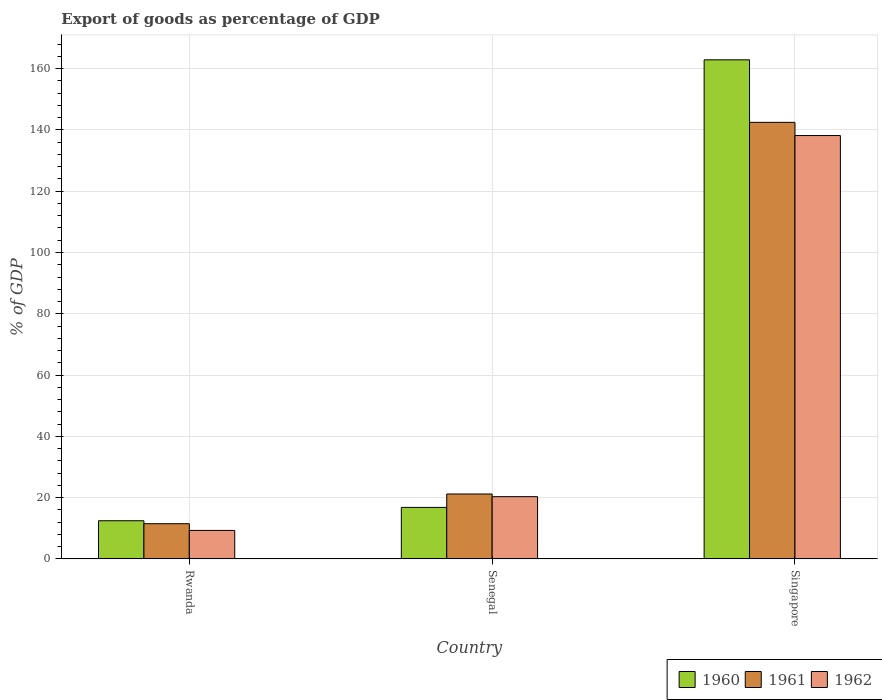How many different coloured bars are there?
Provide a succinct answer. 3. How many groups of bars are there?
Your answer should be very brief. 3. Are the number of bars per tick equal to the number of legend labels?
Provide a succinct answer. Yes. Are the number of bars on each tick of the X-axis equal?
Your answer should be compact. Yes. How many bars are there on the 3rd tick from the right?
Provide a succinct answer. 3. What is the label of the 1st group of bars from the left?
Ensure brevity in your answer.  Rwanda. In how many cases, is the number of bars for a given country not equal to the number of legend labels?
Your response must be concise. 0. What is the export of goods as percentage of GDP in 1960 in Senegal?
Offer a terse response. 16.79. Across all countries, what is the maximum export of goods as percentage of GDP in 1962?
Offer a very short reply. 138.18. Across all countries, what is the minimum export of goods as percentage of GDP in 1961?
Offer a terse response. 11.48. In which country was the export of goods as percentage of GDP in 1960 maximum?
Your response must be concise. Singapore. In which country was the export of goods as percentage of GDP in 1961 minimum?
Ensure brevity in your answer.  Rwanda. What is the total export of goods as percentage of GDP in 1960 in the graph?
Provide a succinct answer. 192.12. What is the difference between the export of goods as percentage of GDP in 1960 in Rwanda and that in Senegal?
Provide a succinct answer. -4.36. What is the difference between the export of goods as percentage of GDP in 1962 in Singapore and the export of goods as percentage of GDP in 1960 in Senegal?
Your response must be concise. 121.39. What is the average export of goods as percentage of GDP in 1960 per country?
Offer a terse response. 64.04. What is the difference between the export of goods as percentage of GDP of/in 1962 and export of goods as percentage of GDP of/in 1960 in Rwanda?
Give a very brief answer. -3.16. In how many countries, is the export of goods as percentage of GDP in 1960 greater than 32 %?
Make the answer very short. 1. What is the ratio of the export of goods as percentage of GDP in 1960 in Rwanda to that in Singapore?
Ensure brevity in your answer.  0.08. Is the difference between the export of goods as percentage of GDP in 1962 in Senegal and Singapore greater than the difference between the export of goods as percentage of GDP in 1960 in Senegal and Singapore?
Your answer should be very brief. Yes. What is the difference between the highest and the second highest export of goods as percentage of GDP in 1961?
Provide a succinct answer. -9.7. What is the difference between the highest and the lowest export of goods as percentage of GDP in 1960?
Ensure brevity in your answer.  150.46. Is the sum of the export of goods as percentage of GDP in 1962 in Senegal and Singapore greater than the maximum export of goods as percentage of GDP in 1960 across all countries?
Your response must be concise. No. Is it the case that in every country, the sum of the export of goods as percentage of GDP in 1962 and export of goods as percentage of GDP in 1960 is greater than the export of goods as percentage of GDP in 1961?
Offer a very short reply. Yes. How many bars are there?
Offer a terse response. 9. Are all the bars in the graph horizontal?
Make the answer very short. No. How many countries are there in the graph?
Give a very brief answer. 3. Are the values on the major ticks of Y-axis written in scientific E-notation?
Your answer should be very brief. No. Does the graph contain any zero values?
Keep it short and to the point. No. Does the graph contain grids?
Offer a terse response. Yes. Where does the legend appear in the graph?
Offer a terse response. Bottom right. How many legend labels are there?
Make the answer very short. 3. How are the legend labels stacked?
Give a very brief answer. Horizontal. What is the title of the graph?
Your answer should be compact. Export of goods as percentage of GDP. What is the label or title of the X-axis?
Your answer should be very brief. Country. What is the label or title of the Y-axis?
Ensure brevity in your answer.  % of GDP. What is the % of GDP in 1960 in Rwanda?
Ensure brevity in your answer.  12.44. What is the % of GDP of 1961 in Rwanda?
Ensure brevity in your answer.  11.48. What is the % of GDP of 1962 in Rwanda?
Provide a short and direct response. 9.28. What is the % of GDP of 1960 in Senegal?
Your response must be concise. 16.79. What is the % of GDP of 1961 in Senegal?
Keep it short and to the point. 21.17. What is the % of GDP in 1962 in Senegal?
Your response must be concise. 20.3. What is the % of GDP of 1960 in Singapore?
Offer a very short reply. 162.89. What is the % of GDP in 1961 in Singapore?
Give a very brief answer. 142.48. What is the % of GDP of 1962 in Singapore?
Ensure brevity in your answer.  138.18. Across all countries, what is the maximum % of GDP of 1960?
Make the answer very short. 162.89. Across all countries, what is the maximum % of GDP of 1961?
Provide a succinct answer. 142.48. Across all countries, what is the maximum % of GDP in 1962?
Ensure brevity in your answer.  138.18. Across all countries, what is the minimum % of GDP of 1960?
Keep it short and to the point. 12.44. Across all countries, what is the minimum % of GDP in 1961?
Offer a very short reply. 11.48. Across all countries, what is the minimum % of GDP of 1962?
Provide a short and direct response. 9.28. What is the total % of GDP in 1960 in the graph?
Offer a very short reply. 192.12. What is the total % of GDP of 1961 in the graph?
Offer a very short reply. 175.13. What is the total % of GDP in 1962 in the graph?
Ensure brevity in your answer.  167.76. What is the difference between the % of GDP of 1960 in Rwanda and that in Senegal?
Provide a short and direct response. -4.36. What is the difference between the % of GDP in 1961 in Rwanda and that in Senegal?
Offer a very short reply. -9.7. What is the difference between the % of GDP of 1962 in Rwanda and that in Senegal?
Give a very brief answer. -11.02. What is the difference between the % of GDP of 1960 in Rwanda and that in Singapore?
Your answer should be very brief. -150.46. What is the difference between the % of GDP in 1961 in Rwanda and that in Singapore?
Provide a succinct answer. -131.01. What is the difference between the % of GDP of 1962 in Rwanda and that in Singapore?
Your answer should be very brief. -128.9. What is the difference between the % of GDP in 1960 in Senegal and that in Singapore?
Make the answer very short. -146.1. What is the difference between the % of GDP of 1961 in Senegal and that in Singapore?
Give a very brief answer. -121.31. What is the difference between the % of GDP of 1962 in Senegal and that in Singapore?
Ensure brevity in your answer.  -117.88. What is the difference between the % of GDP of 1960 in Rwanda and the % of GDP of 1961 in Senegal?
Keep it short and to the point. -8.74. What is the difference between the % of GDP in 1960 in Rwanda and the % of GDP in 1962 in Senegal?
Your answer should be compact. -7.86. What is the difference between the % of GDP of 1961 in Rwanda and the % of GDP of 1962 in Senegal?
Give a very brief answer. -8.83. What is the difference between the % of GDP in 1960 in Rwanda and the % of GDP in 1961 in Singapore?
Provide a short and direct response. -130.05. What is the difference between the % of GDP of 1960 in Rwanda and the % of GDP of 1962 in Singapore?
Keep it short and to the point. -125.74. What is the difference between the % of GDP in 1961 in Rwanda and the % of GDP in 1962 in Singapore?
Make the answer very short. -126.71. What is the difference between the % of GDP in 1960 in Senegal and the % of GDP in 1961 in Singapore?
Ensure brevity in your answer.  -125.69. What is the difference between the % of GDP of 1960 in Senegal and the % of GDP of 1962 in Singapore?
Keep it short and to the point. -121.39. What is the difference between the % of GDP of 1961 in Senegal and the % of GDP of 1962 in Singapore?
Your response must be concise. -117.01. What is the average % of GDP of 1960 per country?
Offer a very short reply. 64.04. What is the average % of GDP of 1961 per country?
Provide a short and direct response. 58.38. What is the average % of GDP of 1962 per country?
Ensure brevity in your answer.  55.92. What is the difference between the % of GDP in 1960 and % of GDP in 1961 in Rwanda?
Give a very brief answer. 0.96. What is the difference between the % of GDP in 1960 and % of GDP in 1962 in Rwanda?
Your answer should be compact. 3.16. What is the difference between the % of GDP in 1961 and % of GDP in 1962 in Rwanda?
Provide a short and direct response. 2.2. What is the difference between the % of GDP of 1960 and % of GDP of 1961 in Senegal?
Give a very brief answer. -4.38. What is the difference between the % of GDP of 1960 and % of GDP of 1962 in Senegal?
Keep it short and to the point. -3.51. What is the difference between the % of GDP of 1961 and % of GDP of 1962 in Senegal?
Your response must be concise. 0.87. What is the difference between the % of GDP in 1960 and % of GDP in 1961 in Singapore?
Your response must be concise. 20.41. What is the difference between the % of GDP of 1960 and % of GDP of 1962 in Singapore?
Offer a terse response. 24.71. What is the difference between the % of GDP of 1961 and % of GDP of 1962 in Singapore?
Give a very brief answer. 4.3. What is the ratio of the % of GDP of 1960 in Rwanda to that in Senegal?
Give a very brief answer. 0.74. What is the ratio of the % of GDP in 1961 in Rwanda to that in Senegal?
Offer a very short reply. 0.54. What is the ratio of the % of GDP of 1962 in Rwanda to that in Senegal?
Your answer should be compact. 0.46. What is the ratio of the % of GDP in 1960 in Rwanda to that in Singapore?
Provide a succinct answer. 0.08. What is the ratio of the % of GDP in 1961 in Rwanda to that in Singapore?
Your answer should be very brief. 0.08. What is the ratio of the % of GDP in 1962 in Rwanda to that in Singapore?
Provide a succinct answer. 0.07. What is the ratio of the % of GDP in 1960 in Senegal to that in Singapore?
Your answer should be compact. 0.1. What is the ratio of the % of GDP of 1961 in Senegal to that in Singapore?
Your response must be concise. 0.15. What is the ratio of the % of GDP in 1962 in Senegal to that in Singapore?
Your answer should be compact. 0.15. What is the difference between the highest and the second highest % of GDP of 1960?
Offer a terse response. 146.1. What is the difference between the highest and the second highest % of GDP in 1961?
Offer a very short reply. 121.31. What is the difference between the highest and the second highest % of GDP of 1962?
Provide a short and direct response. 117.88. What is the difference between the highest and the lowest % of GDP of 1960?
Provide a succinct answer. 150.46. What is the difference between the highest and the lowest % of GDP of 1961?
Offer a terse response. 131.01. What is the difference between the highest and the lowest % of GDP of 1962?
Ensure brevity in your answer.  128.9. 